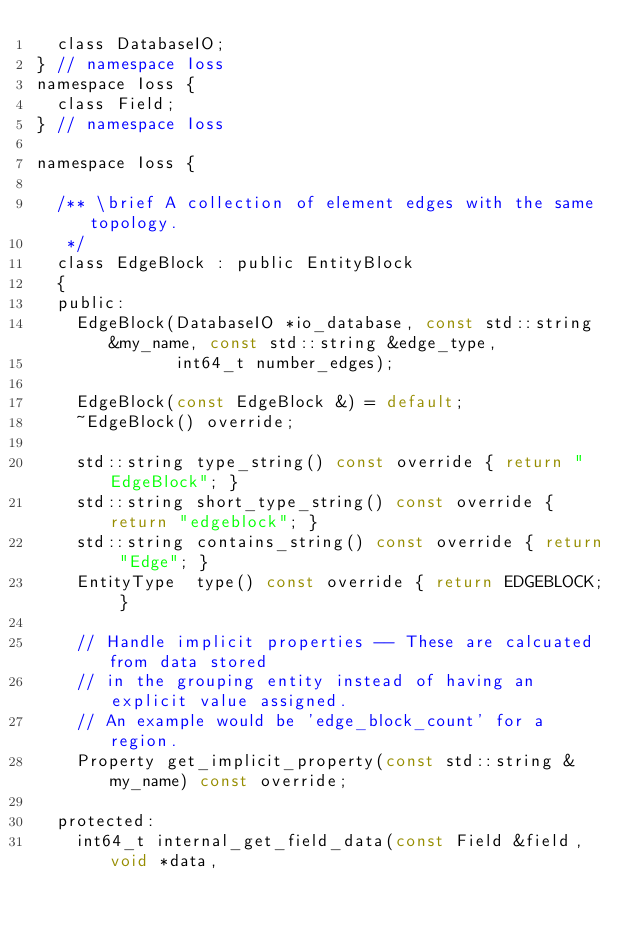Convert code to text. <code><loc_0><loc_0><loc_500><loc_500><_C_>  class DatabaseIO;
} // namespace Ioss
namespace Ioss {
  class Field;
} // namespace Ioss

namespace Ioss {

  /** \brief A collection of element edges with the same topology.
   */
  class EdgeBlock : public EntityBlock
  {
  public:
    EdgeBlock(DatabaseIO *io_database, const std::string &my_name, const std::string &edge_type,
              int64_t number_edges);

    EdgeBlock(const EdgeBlock &) = default;
    ~EdgeBlock() override;

    std::string type_string() const override { return "EdgeBlock"; }
    std::string short_type_string() const override { return "edgeblock"; }
    std::string contains_string() const override { return "Edge"; }
    EntityType  type() const override { return EDGEBLOCK; }

    // Handle implicit properties -- These are calcuated from data stored
    // in the grouping entity instead of having an explicit value assigned.
    // An example would be 'edge_block_count' for a region.
    Property get_implicit_property(const std::string &my_name) const override;

  protected:
    int64_t internal_get_field_data(const Field &field, void *data,</code> 